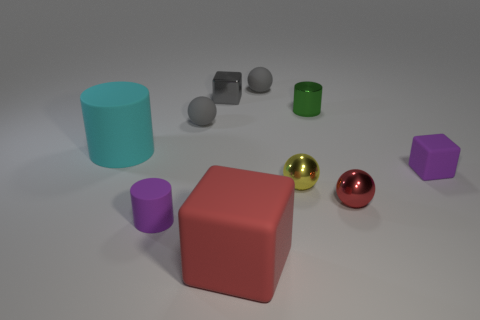How many cyan matte cylinders have the same size as the red matte cube?
Your answer should be very brief. 1. How many other things are the same color as the large cylinder?
Give a very brief answer. 0. Is there anything else that has the same size as the red rubber thing?
Keep it short and to the point. Yes. Do the tiny gray object that is to the right of the small gray block and the purple thing that is on the right side of the purple rubber cylinder have the same shape?
Make the answer very short. No. What shape is the gray shiny thing that is the same size as the green metal cylinder?
Offer a terse response. Cube. Is the number of cylinders on the right side of the tiny purple rubber cube the same as the number of cyan rubber things on the right side of the large red object?
Keep it short and to the point. Yes. Is there any other thing that is the same shape as the red metallic object?
Provide a short and direct response. Yes. Is the small block in front of the gray block made of the same material as the cyan object?
Your answer should be compact. Yes. There is a yellow object that is the same size as the shiny cylinder; what is it made of?
Offer a terse response. Metal. What number of other things are there of the same material as the cyan cylinder
Offer a very short reply. 5. 